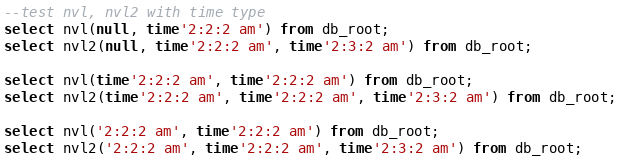<code> <loc_0><loc_0><loc_500><loc_500><_SQL_>--test nvl, nvl2 with time type
select nvl(null, time'2:2:2 am') from db_root;
select nvl2(null, time'2:2:2 am', time'2:3:2 am') from db_root;

select nvl(time'2:2:2 am', time'2:2:2 am') from db_root;
select nvl2(time'2:2:2 am', time'2:2:2 am', time'2:3:2 am') from db_root;

select nvl('2:2:2 am', time'2:2:2 am') from db_root;
select nvl2('2:2:2 am', time'2:2:2 am', time'2:3:2 am') from db_root;
</code> 